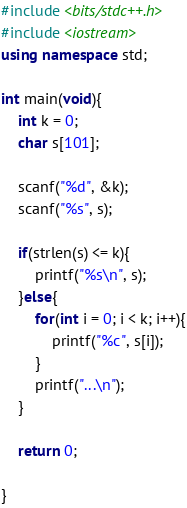Convert code to text. <code><loc_0><loc_0><loc_500><loc_500><_C++_>#include <bits/stdc++.h>
#include <iostream>
using namespace std;

int main(void){
    int k = 0;
    char s[101];

    scanf("%d", &k);
    scanf("%s", s);

    if(strlen(s) <= k){
        printf("%s\n", s);
    }else{
        for(int i = 0; i < k; i++){
            printf("%c", s[i]);
        }
        printf("...\n");
    }

    return 0;

} 
</code> 